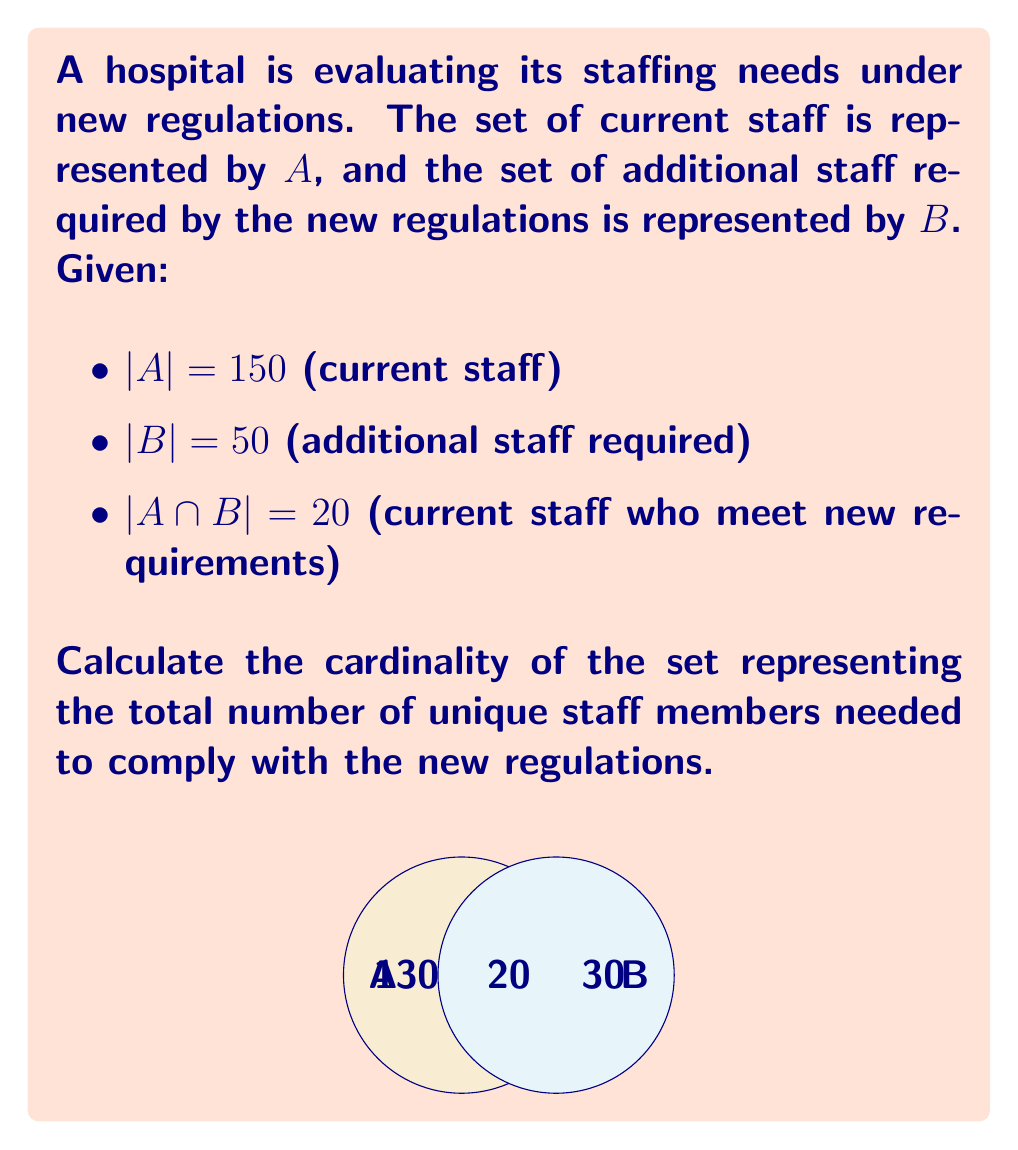Can you answer this question? Let's approach this step-by-step:

1) We need to find $|A \cup B|$, which represents the total number of unique staff members needed.

2) We can use the formula for the cardinality of a union of two sets:

   $$|A \cup B| = |A| + |B| - |A \cap B|$$

3) We're given:
   - $|A| = 150$
   - $|B| = 50$
   - $|A \cap B| = 20$

4) Let's substitute these values into the formula:

   $$|A \cup B| = 150 + 50 - 20$$

5) Now we can calculate:

   $$|A \cup B| = 200 - 20 = 180$$

Therefore, the total number of unique staff members needed to comply with the new regulations is 180.
Answer: 180 